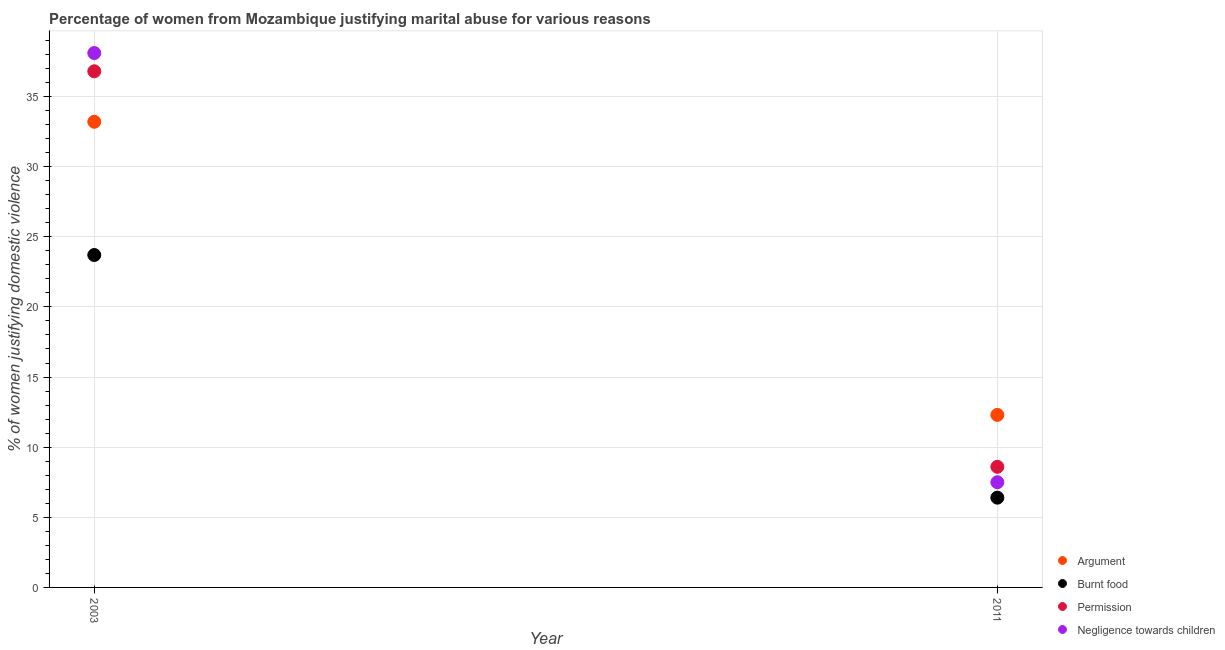How many different coloured dotlines are there?
Your response must be concise. 4. Is the number of dotlines equal to the number of legend labels?
Offer a very short reply. Yes. What is the percentage of women justifying abuse for showing negligence towards children in 2011?
Make the answer very short. 7.5. Across all years, what is the maximum percentage of women justifying abuse for going without permission?
Make the answer very short. 36.8. Across all years, what is the minimum percentage of women justifying abuse for showing negligence towards children?
Keep it short and to the point. 7.5. In which year was the percentage of women justifying abuse for showing negligence towards children minimum?
Offer a very short reply. 2011. What is the total percentage of women justifying abuse for burning food in the graph?
Offer a very short reply. 30.1. What is the difference between the percentage of women justifying abuse for burning food in 2003 and that in 2011?
Offer a terse response. 17.3. What is the difference between the percentage of women justifying abuse for going without permission in 2011 and the percentage of women justifying abuse in the case of an argument in 2003?
Your response must be concise. -24.6. What is the average percentage of women justifying abuse in the case of an argument per year?
Your answer should be compact. 22.75. In the year 2011, what is the difference between the percentage of women justifying abuse for showing negligence towards children and percentage of women justifying abuse for burning food?
Your answer should be compact. 1.1. What is the ratio of the percentage of women justifying abuse for going without permission in 2003 to that in 2011?
Offer a terse response. 4.28. Is it the case that in every year, the sum of the percentage of women justifying abuse in the case of an argument and percentage of women justifying abuse for burning food is greater than the percentage of women justifying abuse for going without permission?
Offer a very short reply. Yes. Is the percentage of women justifying abuse for going without permission strictly less than the percentage of women justifying abuse in the case of an argument over the years?
Offer a terse response. No. Are the values on the major ticks of Y-axis written in scientific E-notation?
Provide a succinct answer. No. Does the graph contain grids?
Provide a succinct answer. Yes. Where does the legend appear in the graph?
Provide a succinct answer. Bottom right. How many legend labels are there?
Give a very brief answer. 4. How are the legend labels stacked?
Your answer should be compact. Vertical. What is the title of the graph?
Make the answer very short. Percentage of women from Mozambique justifying marital abuse for various reasons. What is the label or title of the Y-axis?
Offer a very short reply. % of women justifying domestic violence. What is the % of women justifying domestic violence in Argument in 2003?
Offer a very short reply. 33.2. What is the % of women justifying domestic violence in Burnt food in 2003?
Offer a terse response. 23.7. What is the % of women justifying domestic violence in Permission in 2003?
Your answer should be compact. 36.8. What is the % of women justifying domestic violence of Negligence towards children in 2003?
Your response must be concise. 38.1. What is the % of women justifying domestic violence of Negligence towards children in 2011?
Make the answer very short. 7.5. Across all years, what is the maximum % of women justifying domestic violence in Argument?
Your answer should be compact. 33.2. Across all years, what is the maximum % of women justifying domestic violence of Burnt food?
Keep it short and to the point. 23.7. Across all years, what is the maximum % of women justifying domestic violence of Permission?
Make the answer very short. 36.8. Across all years, what is the maximum % of women justifying domestic violence in Negligence towards children?
Your response must be concise. 38.1. Across all years, what is the minimum % of women justifying domestic violence in Argument?
Your answer should be compact. 12.3. Across all years, what is the minimum % of women justifying domestic violence of Burnt food?
Your response must be concise. 6.4. Across all years, what is the minimum % of women justifying domestic violence of Permission?
Provide a short and direct response. 8.6. Across all years, what is the minimum % of women justifying domestic violence of Negligence towards children?
Your response must be concise. 7.5. What is the total % of women justifying domestic violence of Argument in the graph?
Make the answer very short. 45.5. What is the total % of women justifying domestic violence in Burnt food in the graph?
Make the answer very short. 30.1. What is the total % of women justifying domestic violence in Permission in the graph?
Your answer should be compact. 45.4. What is the total % of women justifying domestic violence of Negligence towards children in the graph?
Your response must be concise. 45.6. What is the difference between the % of women justifying domestic violence of Argument in 2003 and that in 2011?
Make the answer very short. 20.9. What is the difference between the % of women justifying domestic violence in Permission in 2003 and that in 2011?
Keep it short and to the point. 28.2. What is the difference between the % of women justifying domestic violence in Negligence towards children in 2003 and that in 2011?
Keep it short and to the point. 30.6. What is the difference between the % of women justifying domestic violence in Argument in 2003 and the % of women justifying domestic violence in Burnt food in 2011?
Provide a succinct answer. 26.8. What is the difference between the % of women justifying domestic violence of Argument in 2003 and the % of women justifying domestic violence of Permission in 2011?
Give a very brief answer. 24.6. What is the difference between the % of women justifying domestic violence in Argument in 2003 and the % of women justifying domestic violence in Negligence towards children in 2011?
Your response must be concise. 25.7. What is the difference between the % of women justifying domestic violence in Permission in 2003 and the % of women justifying domestic violence in Negligence towards children in 2011?
Your answer should be very brief. 29.3. What is the average % of women justifying domestic violence of Argument per year?
Provide a short and direct response. 22.75. What is the average % of women justifying domestic violence in Burnt food per year?
Provide a short and direct response. 15.05. What is the average % of women justifying domestic violence of Permission per year?
Your answer should be compact. 22.7. What is the average % of women justifying domestic violence in Negligence towards children per year?
Ensure brevity in your answer.  22.8. In the year 2003, what is the difference between the % of women justifying domestic violence of Argument and % of women justifying domestic violence of Burnt food?
Your response must be concise. 9.5. In the year 2003, what is the difference between the % of women justifying domestic violence of Argument and % of women justifying domestic violence of Negligence towards children?
Your response must be concise. -4.9. In the year 2003, what is the difference between the % of women justifying domestic violence in Burnt food and % of women justifying domestic violence in Negligence towards children?
Your answer should be compact. -14.4. In the year 2003, what is the difference between the % of women justifying domestic violence of Permission and % of women justifying domestic violence of Negligence towards children?
Your answer should be compact. -1.3. In the year 2011, what is the difference between the % of women justifying domestic violence in Argument and % of women justifying domestic violence in Burnt food?
Your answer should be very brief. 5.9. In the year 2011, what is the difference between the % of women justifying domestic violence of Burnt food and % of women justifying domestic violence of Permission?
Your answer should be very brief. -2.2. What is the ratio of the % of women justifying domestic violence in Argument in 2003 to that in 2011?
Keep it short and to the point. 2.7. What is the ratio of the % of women justifying domestic violence in Burnt food in 2003 to that in 2011?
Offer a very short reply. 3.7. What is the ratio of the % of women justifying domestic violence in Permission in 2003 to that in 2011?
Your answer should be very brief. 4.28. What is the ratio of the % of women justifying domestic violence of Negligence towards children in 2003 to that in 2011?
Ensure brevity in your answer.  5.08. What is the difference between the highest and the second highest % of women justifying domestic violence of Argument?
Your answer should be compact. 20.9. What is the difference between the highest and the second highest % of women justifying domestic violence in Permission?
Provide a short and direct response. 28.2. What is the difference between the highest and the second highest % of women justifying domestic violence in Negligence towards children?
Your answer should be compact. 30.6. What is the difference between the highest and the lowest % of women justifying domestic violence in Argument?
Your answer should be very brief. 20.9. What is the difference between the highest and the lowest % of women justifying domestic violence in Burnt food?
Provide a succinct answer. 17.3. What is the difference between the highest and the lowest % of women justifying domestic violence in Permission?
Offer a very short reply. 28.2. What is the difference between the highest and the lowest % of women justifying domestic violence of Negligence towards children?
Your answer should be very brief. 30.6. 